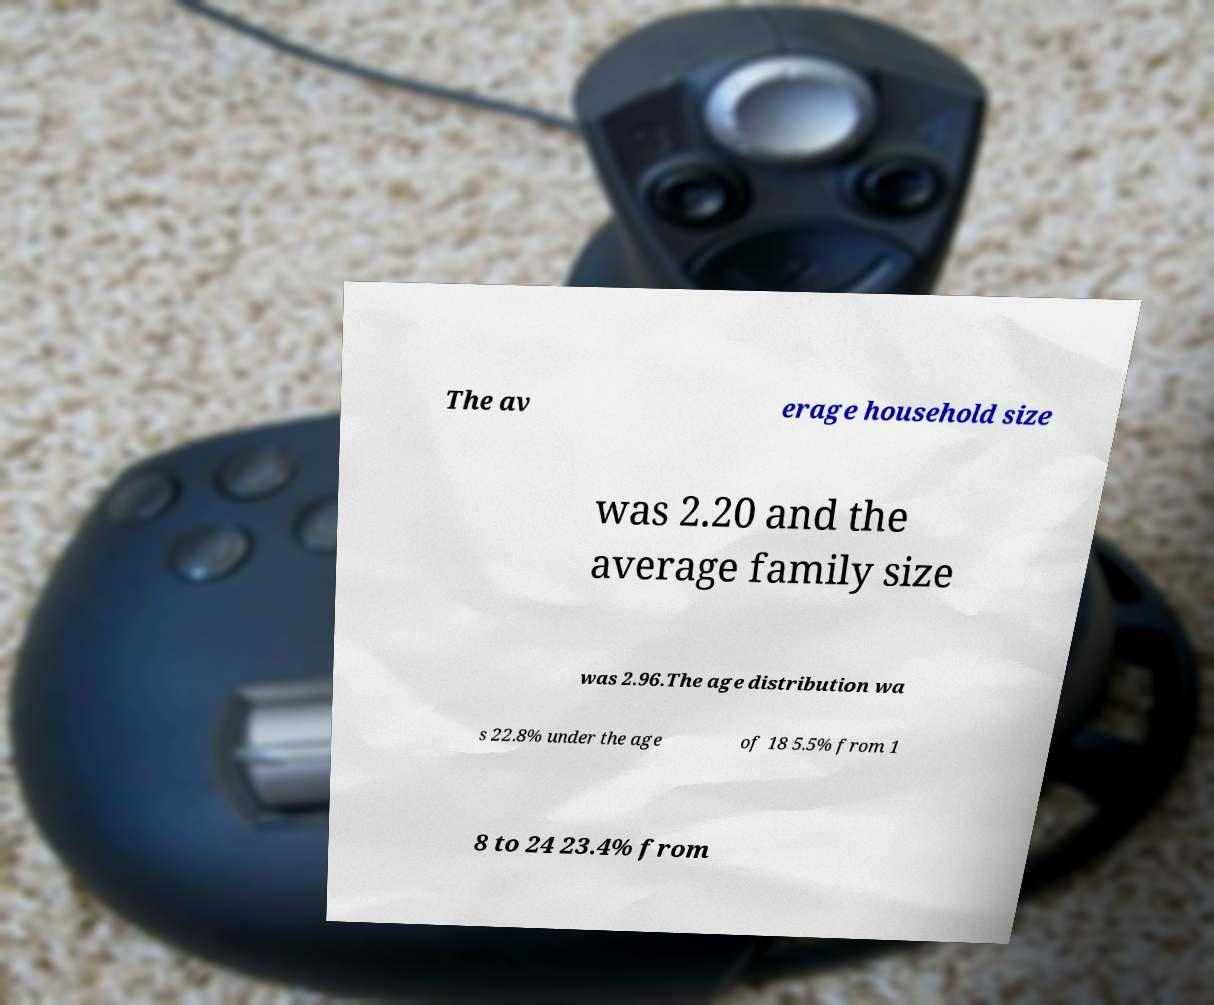For documentation purposes, I need the text within this image transcribed. Could you provide that? The av erage household size was 2.20 and the average family size was 2.96.The age distribution wa s 22.8% under the age of 18 5.5% from 1 8 to 24 23.4% from 